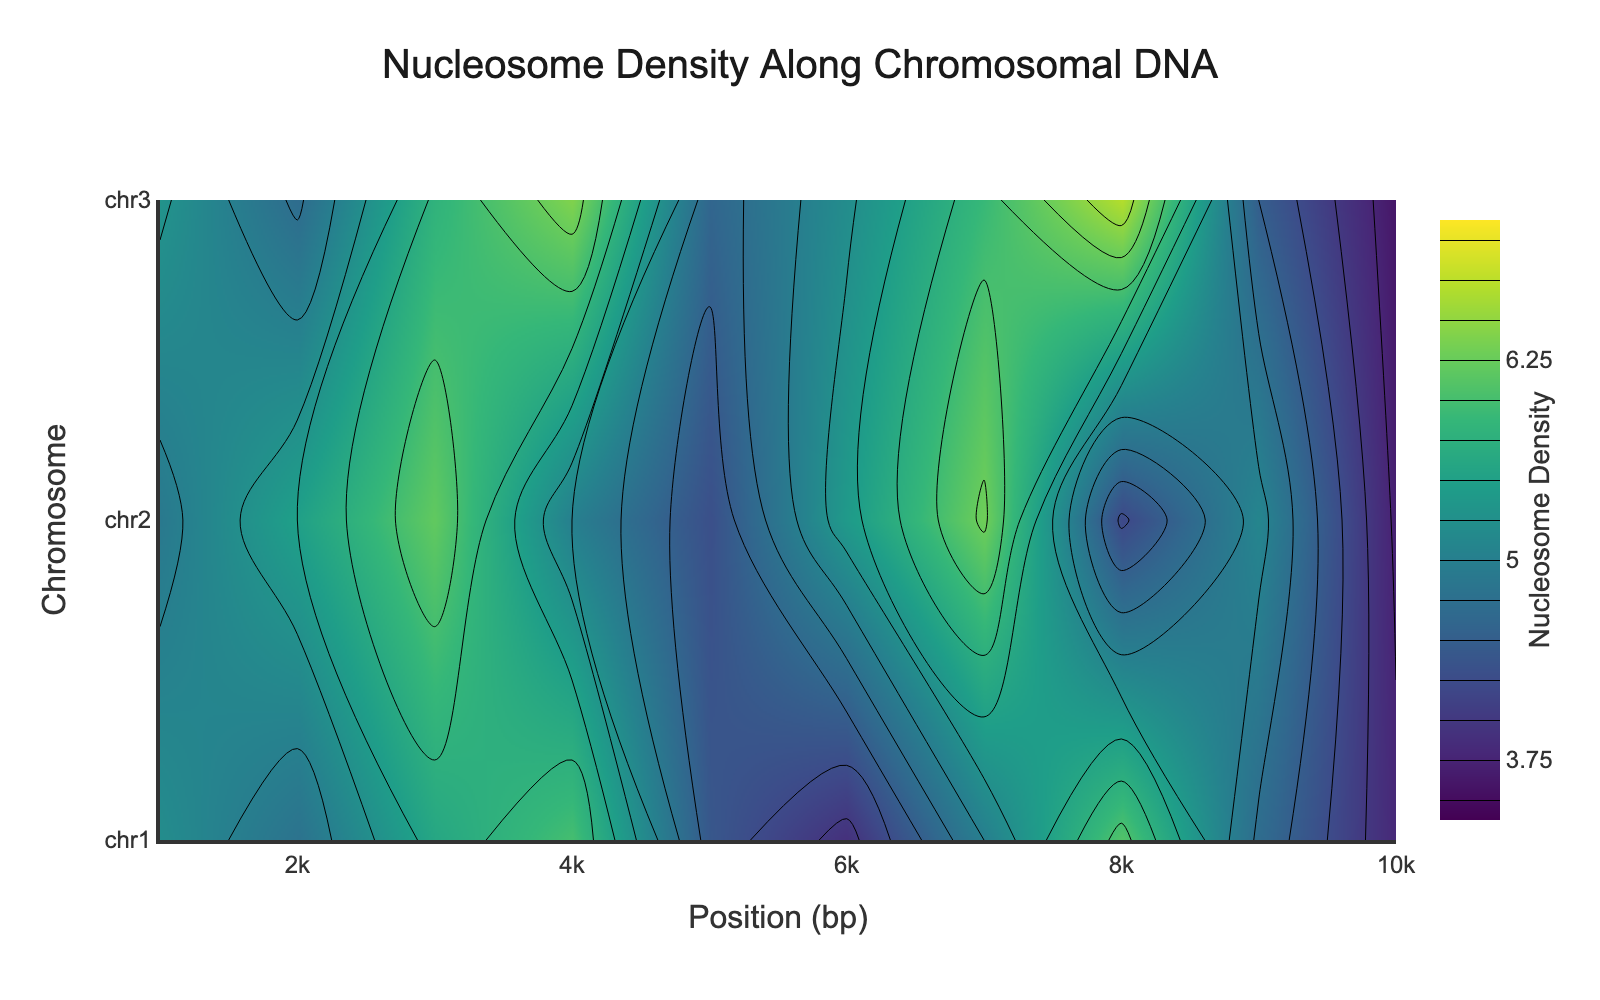What is the title of the plot? To find the title of the plot, locate the text at the top center of the figure. This is usually placed prominently and often larger in size than other text. In this case, the title reads "Nucleosome Density Along Chromosomal DNA."
Answer: "Nucleosome Density Along Chromosomal DNA" What are the x-axis and y-axis labels? To identify the labels for the axes, look at the text next to the horizontal line (x-axis) and the vertical line (y-axis). The x-axis is labeled "Position (bp)," and the y-axis is labeled "Chromosome."
Answer: x-axis: "Position (bp)" and y-axis: "Chromosome" Which chromosome has the highest nucleosome density and what is the position? To determine the chromosome and position with the highest density, look at the color gradient and find the darkest region or highest contour value. According to the plot, the highest density is found in chromosome 3 around position 8000 bp.
Answer: Chromosome 3 at position around 8000 bp Comparing chromosome 1 and chromosome 2, which has a higher nucleosome density around position 6000 bp? Check the color intensity or contour values at position 6000 bp for both chromosomes. From the contour plot, chromosome 2 shows a higher nucleosome density at this position compared to chromosome 1.
Answer: Chromosome 2 What is the range of nucleosome densities plotted on this figure? The colorbar next to the plot provides the range of values displayed in the contour plot. The provided figure indicates that the nucleosome densities range from 3.5 to 7.
Answer: 3.5 to 7 On which chromosome and at what position do we see the lowest nucleosome density? To find the lowest density, find the lightest or least intense color regions on the plot. According to the plot, the lowest density is around 3.6 found on chromosome 3 at position 10000 bp.
Answer: Chromosome 3 at position 10000 bp Is there a general trend in nucleosome density across increasing positions within chromosome 1? Observe the color gradient or contour lines’ arrangement as position increases on chromosome 1. The nucleosome density generally decreases as position increases from 1000 bp to 10000 bp.
Answer: Decreases What is the average nucleosome density across chromosome 2? To calculate the average, collect nucleosome densities at positions 1000, 2000, 3000, 4000, 5000, 6000, 7000, 8000, 9000, and 10000 bp for chromosome 2, then divide by 10. The values are 4.9, 5.5, 6.2, 5.0, 4.3, 5.4, 6.3, 4.2, 5.1, 3.7. Sum is 50.6 so, 50.6/10 = 5.06.
Answer: 5.06 What does the color scale represent in this plot? To understand what the color scale represents, refer to the description next to the colorbar. It indicates the range of nucleosome density values, with specific colors representing different density levels.
Answer: Nucleosome density Which chromosome shows the most variability in nucleosome density? Examine each chromosome for the range of colors or contour lines it covers. Chromosome 3 displays the widest range of densities, showing significant variability.
Answer: Chromosome 3 